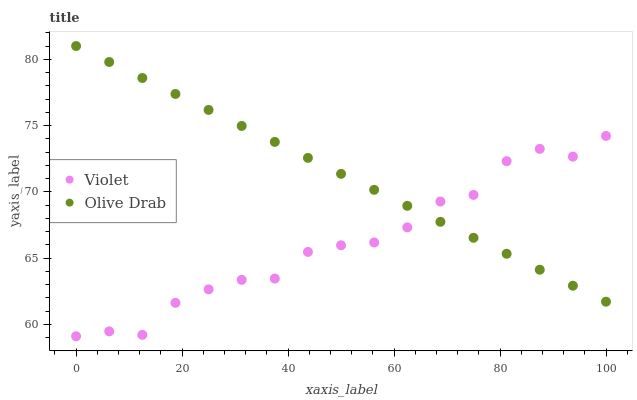Does Violet have the minimum area under the curve?
Answer yes or no. Yes. Does Olive Drab have the maximum area under the curve?
Answer yes or no. Yes. Does Violet have the maximum area under the curve?
Answer yes or no. No. Is Olive Drab the smoothest?
Answer yes or no. Yes. Is Violet the roughest?
Answer yes or no. Yes. Is Violet the smoothest?
Answer yes or no. No. Does Violet have the lowest value?
Answer yes or no. Yes. Does Olive Drab have the highest value?
Answer yes or no. Yes. Does Violet have the highest value?
Answer yes or no. No. Does Olive Drab intersect Violet?
Answer yes or no. Yes. Is Olive Drab less than Violet?
Answer yes or no. No. Is Olive Drab greater than Violet?
Answer yes or no. No. 